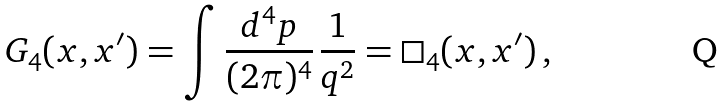<formula> <loc_0><loc_0><loc_500><loc_500>\ G _ { 4 } ( x , x ^ { \prime } ) = \int \frac { d ^ { 4 } p } { ( 2 \pi ) ^ { 4 } } \, \frac { 1 } { q ^ { 2 } } = \square _ { 4 } ( x , x ^ { \prime } ) \, ,</formula> 